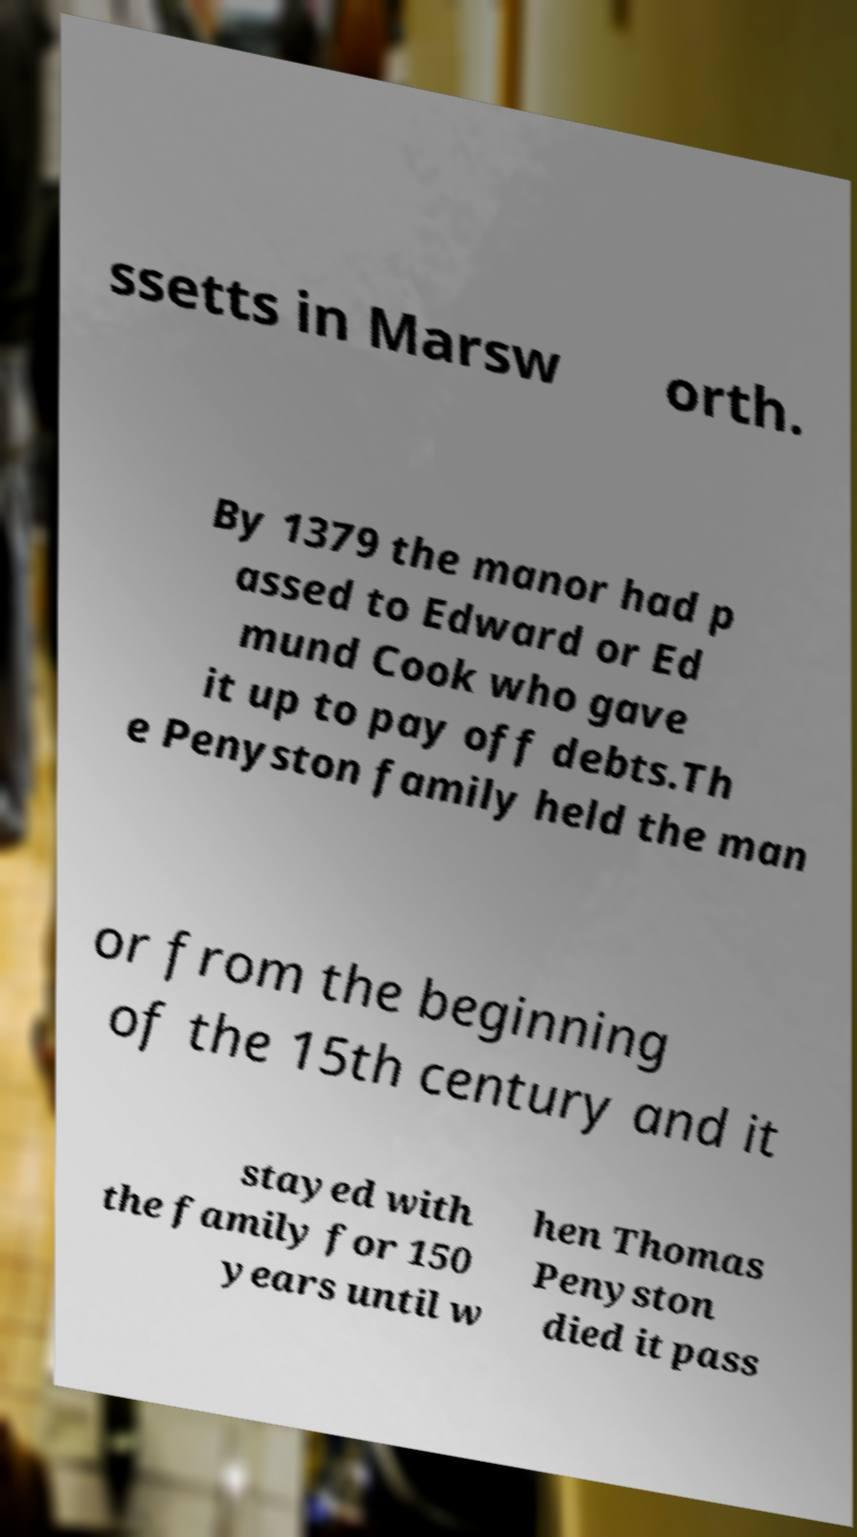Please read and relay the text visible in this image. What does it say? ssetts in Marsw orth. By 1379 the manor had p assed to Edward or Ed mund Cook who gave it up to pay off debts.Th e Penyston family held the man or from the beginning of the 15th century and it stayed with the family for 150 years until w hen Thomas Penyston died it pass 